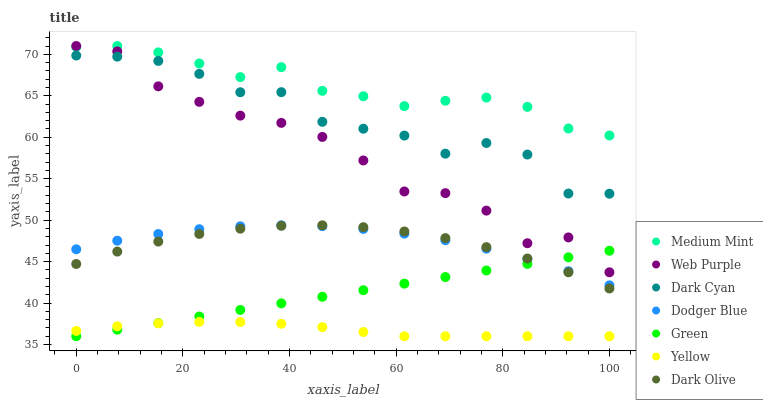Does Yellow have the minimum area under the curve?
Answer yes or no. Yes. Does Medium Mint have the maximum area under the curve?
Answer yes or no. Yes. Does Dark Olive have the minimum area under the curve?
Answer yes or no. No. Does Dark Olive have the maximum area under the curve?
Answer yes or no. No. Is Green the smoothest?
Answer yes or no. Yes. Is Web Purple the roughest?
Answer yes or no. Yes. Is Dark Olive the smoothest?
Answer yes or no. No. Is Dark Olive the roughest?
Answer yes or no. No. Does Yellow have the lowest value?
Answer yes or no. Yes. Does Dark Olive have the lowest value?
Answer yes or no. No. Does Web Purple have the highest value?
Answer yes or no. Yes. Does Dark Olive have the highest value?
Answer yes or no. No. Is Yellow less than Medium Mint?
Answer yes or no. Yes. Is Web Purple greater than Yellow?
Answer yes or no. Yes. Does Dodger Blue intersect Dark Olive?
Answer yes or no. Yes. Is Dodger Blue less than Dark Olive?
Answer yes or no. No. Is Dodger Blue greater than Dark Olive?
Answer yes or no. No. Does Yellow intersect Medium Mint?
Answer yes or no. No. 